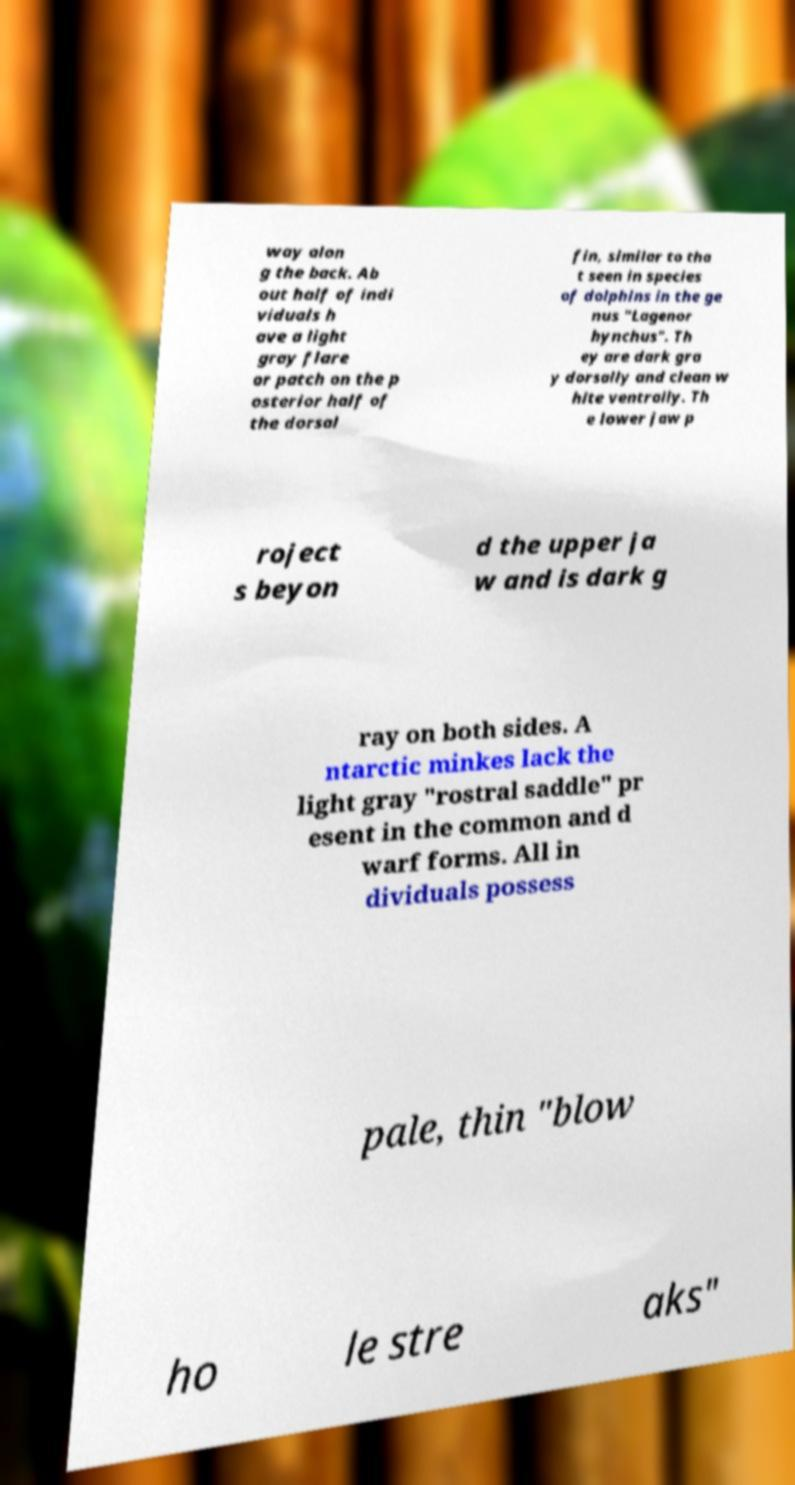Could you extract and type out the text from this image? way alon g the back. Ab out half of indi viduals h ave a light gray flare or patch on the p osterior half of the dorsal fin, similar to tha t seen in species of dolphins in the ge nus "Lagenor hynchus". Th ey are dark gra y dorsally and clean w hite ventrally. Th e lower jaw p roject s beyon d the upper ja w and is dark g ray on both sides. A ntarctic minkes lack the light gray "rostral saddle" pr esent in the common and d warf forms. All in dividuals possess pale, thin "blow ho le stre aks" 